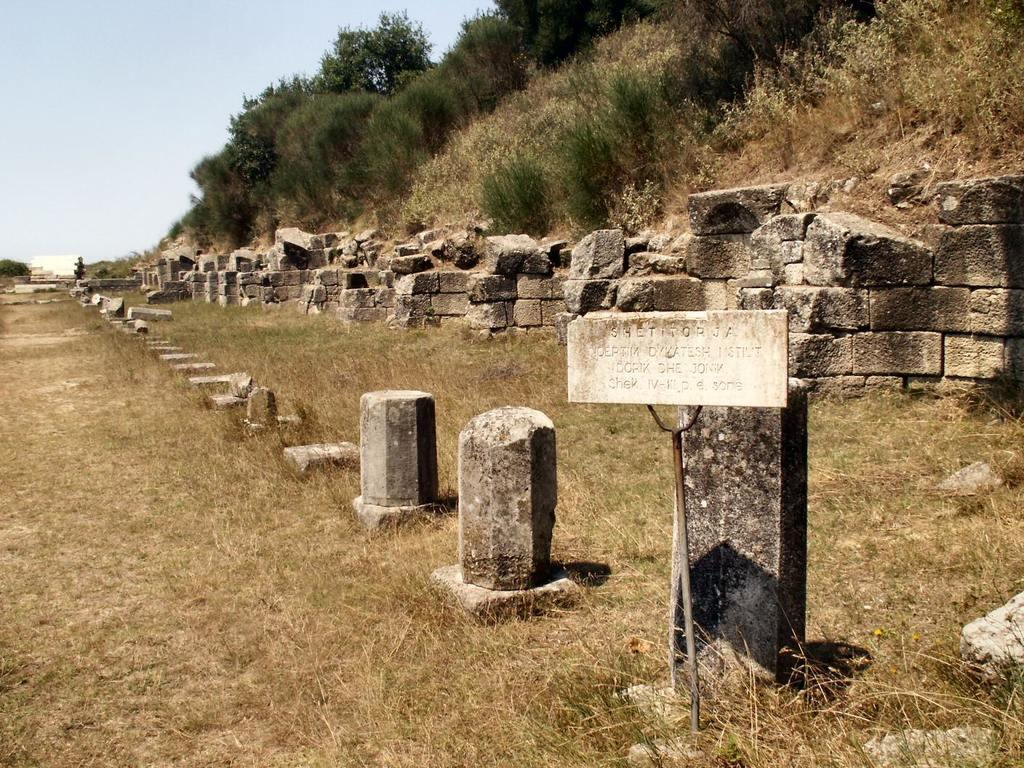What type of natural elements can be seen in the image? There are rocks and trees in the image. What man-made object is present in the image? There is a sign board in the image. What type of plants can be seen growing on the rocks in the image? There are no plants growing on the rocks in the image; only rocks and trees are present. Can you see any ice or frozen elements in the image? There is no ice or frozen elements visible in the image. 